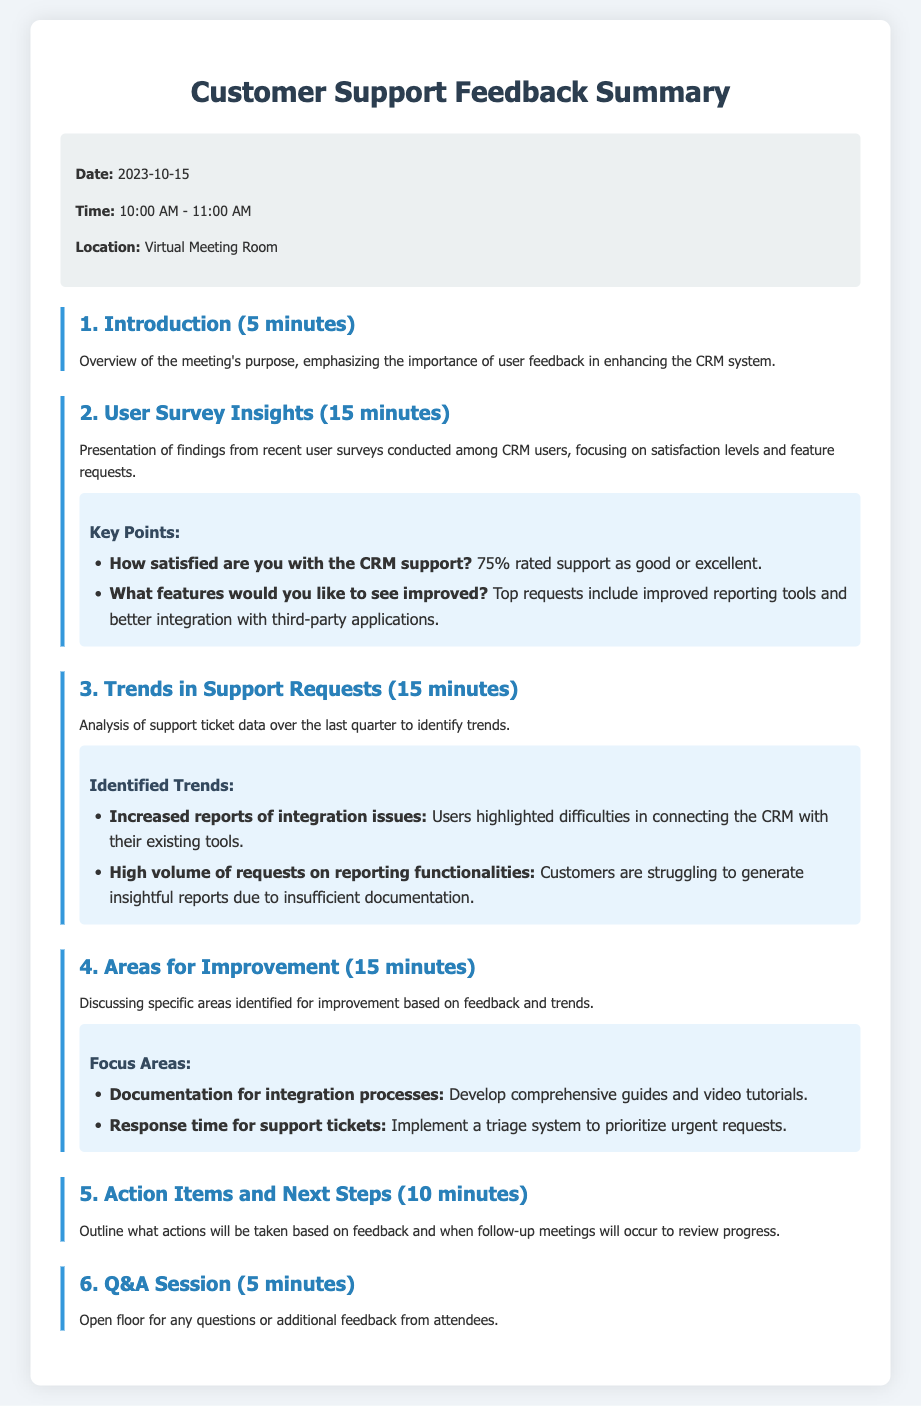What is the date of the meeting? The date of the meeting is explicitly stated in the meeting info section of the document.
Answer: 2023-10-15 How long is the Q&A session? The duration of the Q&A session is mentioned in the agenda outline.
Answer: 5 minutes What percentage of users rated support as good or excellent? The document provides this specific statistic in the user survey insights.
Answer: 75% What is one of the top requests for feature improvements? The document lists specific feature requests in the key points under user survey insights.
Answer: Improved reporting tools What is a key identified trend in support requests? Analyzing the support ticket data reveals trends, which are explicitly stated in the document.
Answer: Increased reports of integration issues What are the focus areas for improvement based on user feedback? The document outlines specific areas for improvement in the corresponding section.
Answer: Documentation for integration processes What action will be taken in response to the feedback? The meeting will summarize actions based on discussed feedback and set timelines in the action items section.
Answer: Triage system What was the purpose of the introduction? The introductory section emphasizes the importance of user feedback regarding the overall meeting intent.
Answer: Enhancing the CRM system What is discussed during the user survey insights? The agenda specifically states the main topics covered in user survey insights.
Answer: Satisfaction levels and feature requests 